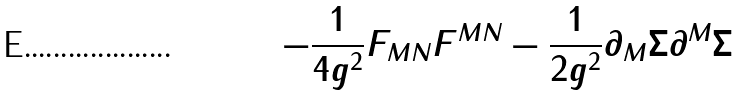Convert formula to latex. <formula><loc_0><loc_0><loc_500><loc_500>- \frac { 1 } { 4 g ^ { 2 } } F _ { M N } F ^ { M N } - \frac { 1 } { 2 g ^ { 2 } } \partial _ { M } \Sigma \partial ^ { M } \Sigma</formula> 